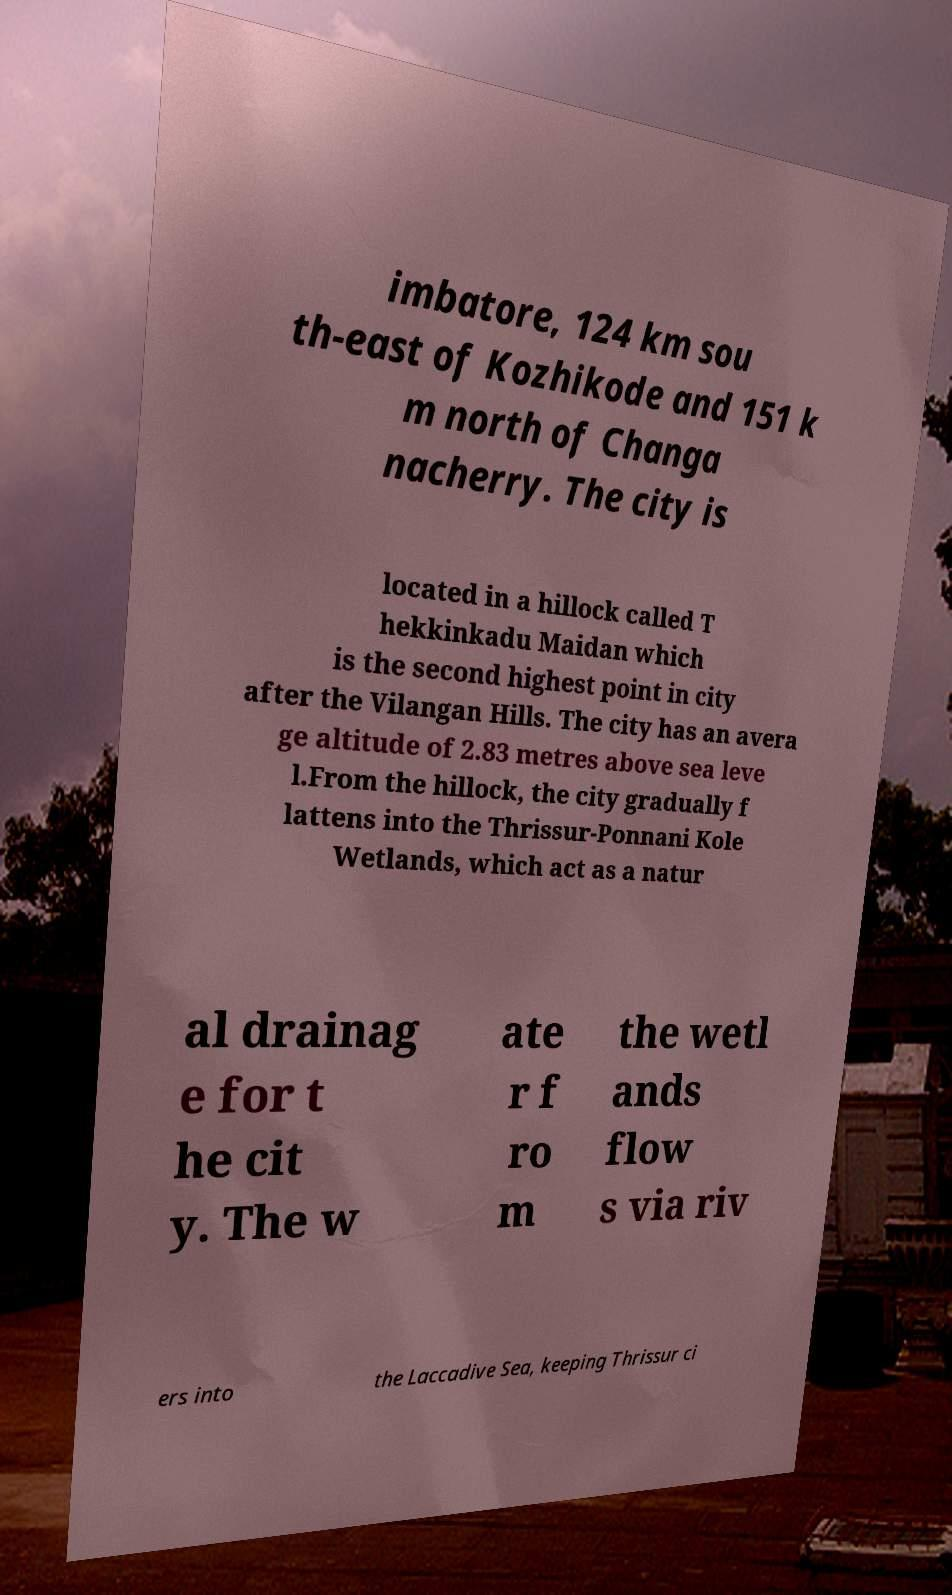Could you extract and type out the text from this image? imbatore, 124 km sou th-east of Kozhikode and 151 k m north of Changa nacherry. The city is located in a hillock called T hekkinkadu Maidan which is the second highest point in city after the Vilangan Hills. The city has an avera ge altitude of 2.83 metres above sea leve l.From the hillock, the city gradually f lattens into the Thrissur-Ponnani Kole Wetlands, which act as a natur al drainag e for t he cit y. The w ate r f ro m the wetl ands flow s via riv ers into the Laccadive Sea, keeping Thrissur ci 